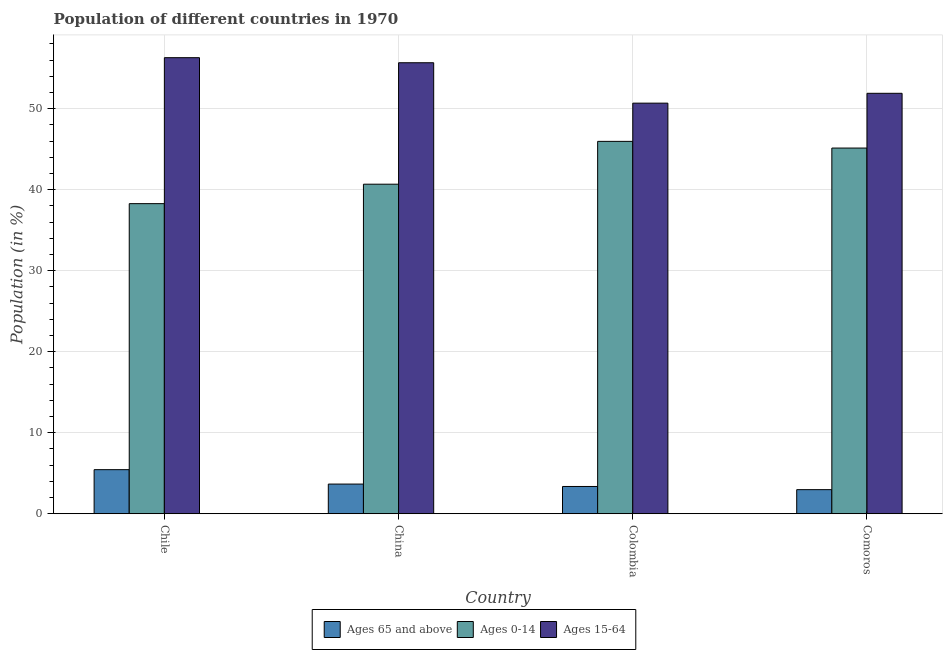How many groups of bars are there?
Give a very brief answer. 4. Are the number of bars on each tick of the X-axis equal?
Keep it short and to the point. Yes. How many bars are there on the 3rd tick from the right?
Provide a succinct answer. 3. In how many cases, is the number of bars for a given country not equal to the number of legend labels?
Your answer should be compact. 0. What is the percentage of population within the age-group 15-64 in Comoros?
Keep it short and to the point. 51.89. Across all countries, what is the maximum percentage of population within the age-group 15-64?
Provide a short and direct response. 56.29. Across all countries, what is the minimum percentage of population within the age-group 0-14?
Give a very brief answer. 38.27. In which country was the percentage of population within the age-group 0-14 maximum?
Offer a very short reply. Colombia. In which country was the percentage of population within the age-group of 65 and above minimum?
Give a very brief answer. Comoros. What is the total percentage of population within the age-group of 65 and above in the graph?
Your answer should be compact. 15.44. What is the difference between the percentage of population within the age-group 0-14 in China and that in Colombia?
Provide a short and direct response. -5.29. What is the difference between the percentage of population within the age-group 15-64 in China and the percentage of population within the age-group of 65 and above in Comoros?
Ensure brevity in your answer.  52.69. What is the average percentage of population within the age-group 0-14 per country?
Ensure brevity in your answer.  42.51. What is the difference between the percentage of population within the age-group of 65 and above and percentage of population within the age-group 0-14 in China?
Keep it short and to the point. -37.01. In how many countries, is the percentage of population within the age-group of 65 and above greater than 40 %?
Your answer should be very brief. 0. What is the ratio of the percentage of population within the age-group 0-14 in Chile to that in Colombia?
Your answer should be compact. 0.83. What is the difference between the highest and the second highest percentage of population within the age-group of 65 and above?
Ensure brevity in your answer.  1.78. What is the difference between the highest and the lowest percentage of population within the age-group 15-64?
Make the answer very short. 5.61. In how many countries, is the percentage of population within the age-group 15-64 greater than the average percentage of population within the age-group 15-64 taken over all countries?
Offer a very short reply. 2. Is the sum of the percentage of population within the age-group 15-64 in Chile and China greater than the maximum percentage of population within the age-group 0-14 across all countries?
Your answer should be very brief. Yes. What does the 1st bar from the left in China represents?
Offer a very short reply. Ages 65 and above. What does the 2nd bar from the right in China represents?
Your response must be concise. Ages 0-14. How many countries are there in the graph?
Give a very brief answer. 4. Does the graph contain any zero values?
Offer a very short reply. No. How many legend labels are there?
Your answer should be very brief. 3. What is the title of the graph?
Your response must be concise. Population of different countries in 1970. Does "Poland" appear as one of the legend labels in the graph?
Give a very brief answer. No. What is the Population (in %) of Ages 65 and above in Chile?
Your answer should be compact. 5.44. What is the Population (in %) in Ages 0-14 in Chile?
Your answer should be very brief. 38.27. What is the Population (in %) in Ages 15-64 in Chile?
Offer a very short reply. 56.29. What is the Population (in %) in Ages 65 and above in China?
Your answer should be compact. 3.66. What is the Population (in %) in Ages 0-14 in China?
Ensure brevity in your answer.  40.67. What is the Population (in %) of Ages 15-64 in China?
Your answer should be compact. 55.66. What is the Population (in %) in Ages 65 and above in Colombia?
Offer a terse response. 3.36. What is the Population (in %) in Ages 0-14 in Colombia?
Offer a very short reply. 45.96. What is the Population (in %) in Ages 15-64 in Colombia?
Provide a short and direct response. 50.68. What is the Population (in %) of Ages 65 and above in Comoros?
Provide a succinct answer. 2.97. What is the Population (in %) in Ages 0-14 in Comoros?
Offer a very short reply. 45.14. What is the Population (in %) of Ages 15-64 in Comoros?
Provide a short and direct response. 51.89. Across all countries, what is the maximum Population (in %) of Ages 65 and above?
Give a very brief answer. 5.44. Across all countries, what is the maximum Population (in %) of Ages 0-14?
Give a very brief answer. 45.96. Across all countries, what is the maximum Population (in %) of Ages 15-64?
Your answer should be compact. 56.29. Across all countries, what is the minimum Population (in %) of Ages 65 and above?
Provide a succinct answer. 2.97. Across all countries, what is the minimum Population (in %) of Ages 0-14?
Your answer should be very brief. 38.27. Across all countries, what is the minimum Population (in %) of Ages 15-64?
Your answer should be very brief. 50.68. What is the total Population (in %) of Ages 65 and above in the graph?
Offer a very short reply. 15.44. What is the total Population (in %) in Ages 0-14 in the graph?
Give a very brief answer. 170.04. What is the total Population (in %) in Ages 15-64 in the graph?
Your answer should be compact. 214.52. What is the difference between the Population (in %) in Ages 65 and above in Chile and that in China?
Your answer should be compact. 1.78. What is the difference between the Population (in %) of Ages 0-14 in Chile and that in China?
Make the answer very short. -2.4. What is the difference between the Population (in %) in Ages 15-64 in Chile and that in China?
Provide a short and direct response. 0.62. What is the difference between the Population (in %) of Ages 65 and above in Chile and that in Colombia?
Give a very brief answer. 2.08. What is the difference between the Population (in %) in Ages 0-14 in Chile and that in Colombia?
Provide a short and direct response. -7.69. What is the difference between the Population (in %) in Ages 15-64 in Chile and that in Colombia?
Give a very brief answer. 5.61. What is the difference between the Population (in %) in Ages 65 and above in Chile and that in Comoros?
Keep it short and to the point. 2.47. What is the difference between the Population (in %) in Ages 0-14 in Chile and that in Comoros?
Make the answer very short. -6.86. What is the difference between the Population (in %) of Ages 15-64 in Chile and that in Comoros?
Ensure brevity in your answer.  4.4. What is the difference between the Population (in %) of Ages 65 and above in China and that in Colombia?
Make the answer very short. 0.3. What is the difference between the Population (in %) of Ages 0-14 in China and that in Colombia?
Provide a short and direct response. -5.29. What is the difference between the Population (in %) of Ages 15-64 in China and that in Colombia?
Ensure brevity in your answer.  4.99. What is the difference between the Population (in %) of Ages 65 and above in China and that in Comoros?
Your response must be concise. 0.69. What is the difference between the Population (in %) of Ages 0-14 in China and that in Comoros?
Provide a short and direct response. -4.46. What is the difference between the Population (in %) in Ages 15-64 in China and that in Comoros?
Your response must be concise. 3.77. What is the difference between the Population (in %) in Ages 65 and above in Colombia and that in Comoros?
Make the answer very short. 0.39. What is the difference between the Population (in %) in Ages 0-14 in Colombia and that in Comoros?
Give a very brief answer. 0.82. What is the difference between the Population (in %) in Ages 15-64 in Colombia and that in Comoros?
Ensure brevity in your answer.  -1.22. What is the difference between the Population (in %) in Ages 65 and above in Chile and the Population (in %) in Ages 0-14 in China?
Your answer should be compact. -35.24. What is the difference between the Population (in %) of Ages 65 and above in Chile and the Population (in %) of Ages 15-64 in China?
Keep it short and to the point. -50.23. What is the difference between the Population (in %) of Ages 0-14 in Chile and the Population (in %) of Ages 15-64 in China?
Offer a very short reply. -17.39. What is the difference between the Population (in %) in Ages 65 and above in Chile and the Population (in %) in Ages 0-14 in Colombia?
Provide a succinct answer. -40.52. What is the difference between the Population (in %) of Ages 65 and above in Chile and the Population (in %) of Ages 15-64 in Colombia?
Offer a terse response. -45.24. What is the difference between the Population (in %) of Ages 0-14 in Chile and the Population (in %) of Ages 15-64 in Colombia?
Offer a terse response. -12.4. What is the difference between the Population (in %) of Ages 65 and above in Chile and the Population (in %) of Ages 0-14 in Comoros?
Your answer should be compact. -39.7. What is the difference between the Population (in %) in Ages 65 and above in Chile and the Population (in %) in Ages 15-64 in Comoros?
Your answer should be very brief. -46.45. What is the difference between the Population (in %) of Ages 0-14 in Chile and the Population (in %) of Ages 15-64 in Comoros?
Your response must be concise. -13.62. What is the difference between the Population (in %) of Ages 65 and above in China and the Population (in %) of Ages 0-14 in Colombia?
Provide a succinct answer. -42.3. What is the difference between the Population (in %) of Ages 65 and above in China and the Population (in %) of Ages 15-64 in Colombia?
Your answer should be very brief. -47.02. What is the difference between the Population (in %) of Ages 0-14 in China and the Population (in %) of Ages 15-64 in Colombia?
Offer a terse response. -10. What is the difference between the Population (in %) of Ages 65 and above in China and the Population (in %) of Ages 0-14 in Comoros?
Give a very brief answer. -41.47. What is the difference between the Population (in %) in Ages 65 and above in China and the Population (in %) in Ages 15-64 in Comoros?
Keep it short and to the point. -48.23. What is the difference between the Population (in %) of Ages 0-14 in China and the Population (in %) of Ages 15-64 in Comoros?
Provide a short and direct response. -11.22. What is the difference between the Population (in %) in Ages 65 and above in Colombia and the Population (in %) in Ages 0-14 in Comoros?
Give a very brief answer. -41.77. What is the difference between the Population (in %) of Ages 65 and above in Colombia and the Population (in %) of Ages 15-64 in Comoros?
Your answer should be very brief. -48.53. What is the difference between the Population (in %) of Ages 0-14 in Colombia and the Population (in %) of Ages 15-64 in Comoros?
Offer a very short reply. -5.93. What is the average Population (in %) of Ages 65 and above per country?
Your response must be concise. 3.86. What is the average Population (in %) of Ages 0-14 per country?
Keep it short and to the point. 42.51. What is the average Population (in %) of Ages 15-64 per country?
Your response must be concise. 53.63. What is the difference between the Population (in %) in Ages 65 and above and Population (in %) in Ages 0-14 in Chile?
Your answer should be compact. -32.83. What is the difference between the Population (in %) in Ages 65 and above and Population (in %) in Ages 15-64 in Chile?
Provide a short and direct response. -50.85. What is the difference between the Population (in %) of Ages 0-14 and Population (in %) of Ages 15-64 in Chile?
Offer a very short reply. -18.02. What is the difference between the Population (in %) in Ages 65 and above and Population (in %) in Ages 0-14 in China?
Ensure brevity in your answer.  -37.01. What is the difference between the Population (in %) of Ages 65 and above and Population (in %) of Ages 15-64 in China?
Provide a short and direct response. -52. What is the difference between the Population (in %) in Ages 0-14 and Population (in %) in Ages 15-64 in China?
Provide a short and direct response. -14.99. What is the difference between the Population (in %) in Ages 65 and above and Population (in %) in Ages 0-14 in Colombia?
Make the answer very short. -42.6. What is the difference between the Population (in %) of Ages 65 and above and Population (in %) of Ages 15-64 in Colombia?
Your response must be concise. -47.31. What is the difference between the Population (in %) in Ages 0-14 and Population (in %) in Ages 15-64 in Colombia?
Your response must be concise. -4.72. What is the difference between the Population (in %) in Ages 65 and above and Population (in %) in Ages 0-14 in Comoros?
Keep it short and to the point. -42.16. What is the difference between the Population (in %) in Ages 65 and above and Population (in %) in Ages 15-64 in Comoros?
Your answer should be very brief. -48.92. What is the difference between the Population (in %) in Ages 0-14 and Population (in %) in Ages 15-64 in Comoros?
Give a very brief answer. -6.76. What is the ratio of the Population (in %) in Ages 65 and above in Chile to that in China?
Make the answer very short. 1.49. What is the ratio of the Population (in %) of Ages 0-14 in Chile to that in China?
Provide a succinct answer. 0.94. What is the ratio of the Population (in %) of Ages 15-64 in Chile to that in China?
Provide a succinct answer. 1.01. What is the ratio of the Population (in %) of Ages 65 and above in Chile to that in Colombia?
Offer a very short reply. 1.62. What is the ratio of the Population (in %) in Ages 0-14 in Chile to that in Colombia?
Your response must be concise. 0.83. What is the ratio of the Population (in %) of Ages 15-64 in Chile to that in Colombia?
Offer a terse response. 1.11. What is the ratio of the Population (in %) in Ages 65 and above in Chile to that in Comoros?
Make the answer very short. 1.83. What is the ratio of the Population (in %) in Ages 0-14 in Chile to that in Comoros?
Offer a very short reply. 0.85. What is the ratio of the Population (in %) in Ages 15-64 in Chile to that in Comoros?
Ensure brevity in your answer.  1.08. What is the ratio of the Population (in %) of Ages 65 and above in China to that in Colombia?
Your answer should be very brief. 1.09. What is the ratio of the Population (in %) in Ages 0-14 in China to that in Colombia?
Give a very brief answer. 0.89. What is the ratio of the Population (in %) of Ages 15-64 in China to that in Colombia?
Your response must be concise. 1.1. What is the ratio of the Population (in %) in Ages 65 and above in China to that in Comoros?
Keep it short and to the point. 1.23. What is the ratio of the Population (in %) of Ages 0-14 in China to that in Comoros?
Ensure brevity in your answer.  0.9. What is the ratio of the Population (in %) of Ages 15-64 in China to that in Comoros?
Make the answer very short. 1.07. What is the ratio of the Population (in %) of Ages 65 and above in Colombia to that in Comoros?
Offer a terse response. 1.13. What is the ratio of the Population (in %) of Ages 0-14 in Colombia to that in Comoros?
Your answer should be compact. 1.02. What is the ratio of the Population (in %) in Ages 15-64 in Colombia to that in Comoros?
Provide a succinct answer. 0.98. What is the difference between the highest and the second highest Population (in %) of Ages 65 and above?
Make the answer very short. 1.78. What is the difference between the highest and the second highest Population (in %) of Ages 0-14?
Provide a short and direct response. 0.82. What is the difference between the highest and the second highest Population (in %) of Ages 15-64?
Make the answer very short. 0.62. What is the difference between the highest and the lowest Population (in %) in Ages 65 and above?
Provide a short and direct response. 2.47. What is the difference between the highest and the lowest Population (in %) in Ages 0-14?
Your response must be concise. 7.69. What is the difference between the highest and the lowest Population (in %) in Ages 15-64?
Keep it short and to the point. 5.61. 